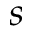<formula> <loc_0><loc_0><loc_500><loc_500>s</formula> 